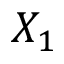Convert formula to latex. <formula><loc_0><loc_0><loc_500><loc_500>X _ { 1 }</formula> 